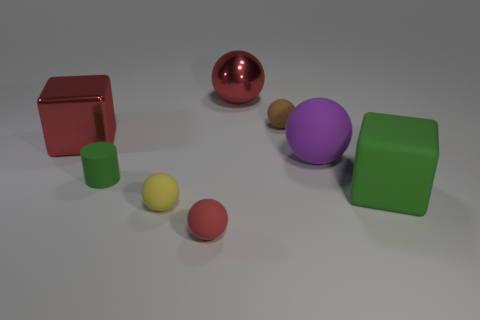Subtract all yellow balls. Subtract all purple cylinders. How many balls are left? 4 Add 2 shiny spheres. How many objects exist? 10 Subtract all blocks. How many objects are left? 6 Add 3 tiny metal spheres. How many tiny metal spheres exist? 3 Subtract 1 yellow spheres. How many objects are left? 7 Subtract all cyan metal spheres. Subtract all red metal balls. How many objects are left? 7 Add 8 big rubber cubes. How many big rubber cubes are left? 9 